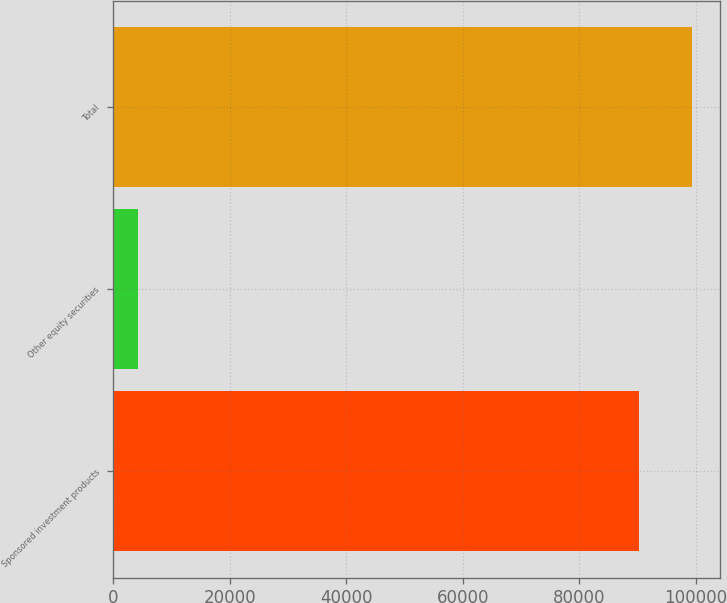Convert chart to OTSL. <chart><loc_0><loc_0><loc_500><loc_500><bar_chart><fcel>Sponsored investment products<fcel>Other equity securities<fcel>Total<nl><fcel>90210<fcel>4200<fcel>99231<nl></chart> 